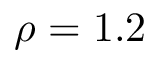<formula> <loc_0><loc_0><loc_500><loc_500>\rho = 1 . 2</formula> 